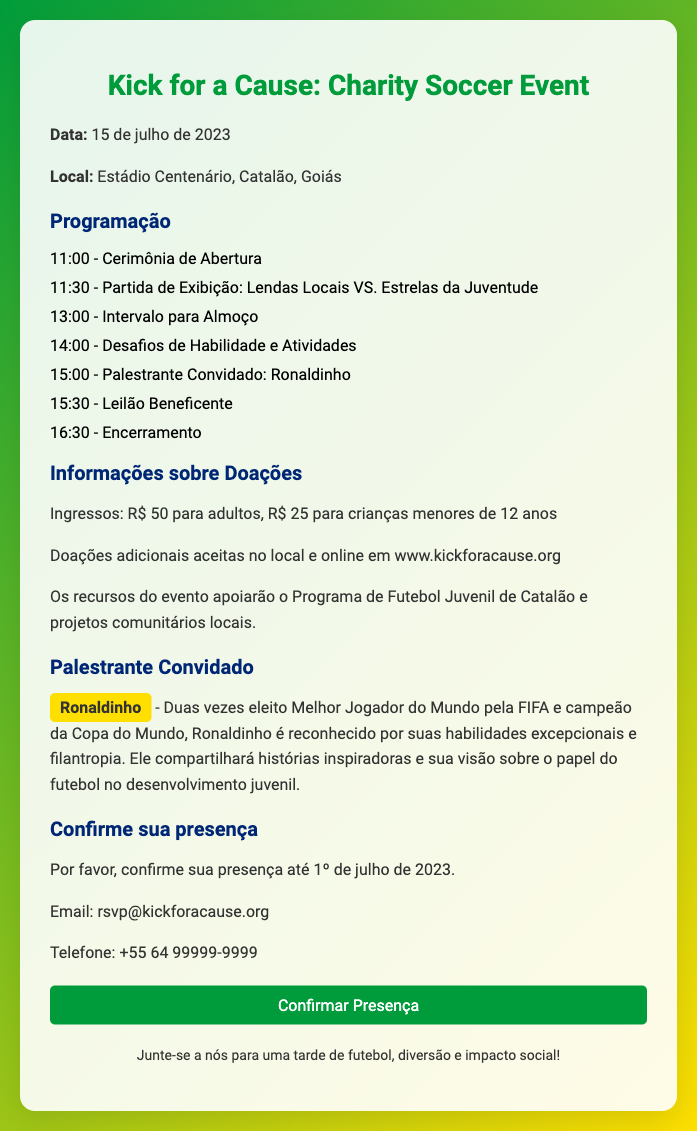What is the event date? The event is scheduled for the 15th of July, 2023, as mentioned in the document.
Answer: 15 de julho de 2023 Where is the event taking place? The location of the event is specified as Estádio Centenário, Catalão, Goiás.
Answer: Estádio Centenário, Catalão, Goiás Who is the guest speaker? The guest speaker is clearly identified as Ronaldinho in the document.
Answer: Ronaldinho What time does the opening ceremony start? The opening ceremony is listed to start at 11:00.
Answer: 11:00 What is the ticket price for adults? The document states the adult ticket price is R$ 50.
Answer: R$ 50 What is the deadline to confirm attendance? The RSVP deadline is given as the 1st of July, 2023.
Answer: 1º de julho de 2023 What activities will take place during the event? A list of activities including a match, skill challenges, and a charity auction indicates there will be a variety of events.
Answer: Cerimônia de Abertura, Partida de Exibição, Intervalo para Almoço, Desafios de Habilidade, Palestrante Convidado, Leilão Beneficente What organization will benefit from the event proceeds? The document mentions that the proceeds will support the Programa de Futebol Juvenil de Catalão.
Answer: Programa de Futebol Juvenil de Catalão What online platform is mentioned for donations? The online platform for donations is specified as www.kickforacause.org.
Answer: www.kickforacause.org 